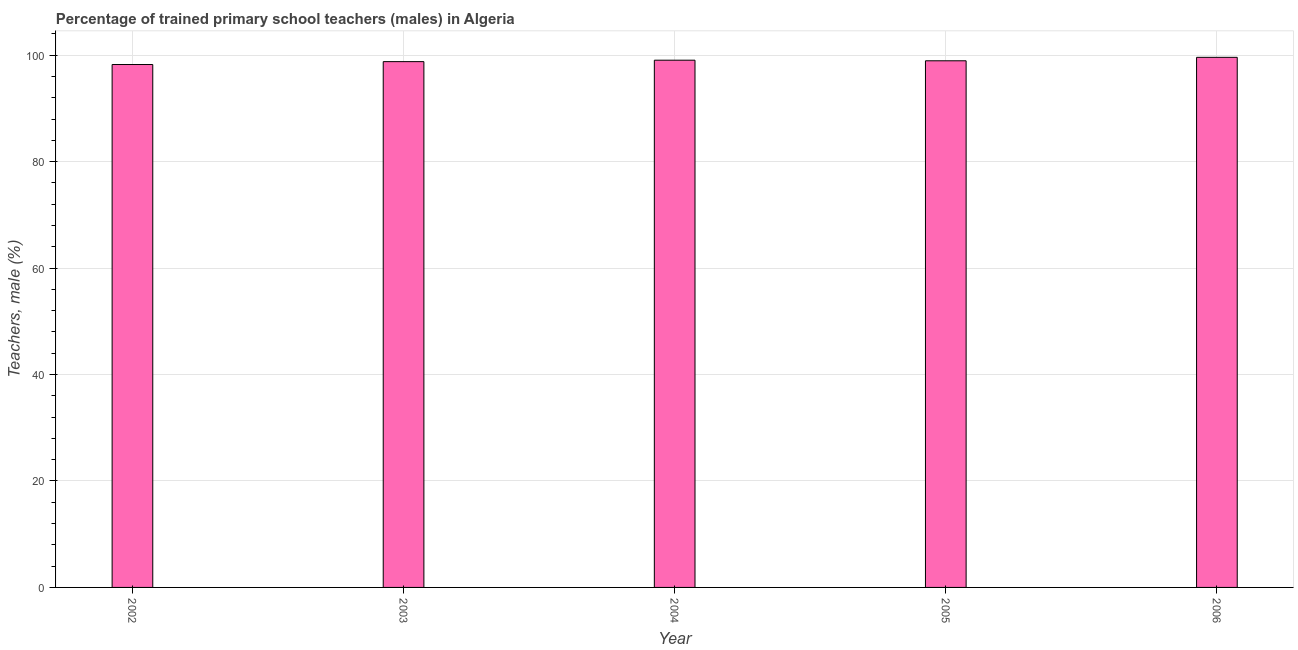Does the graph contain any zero values?
Provide a succinct answer. No. Does the graph contain grids?
Provide a short and direct response. Yes. What is the title of the graph?
Offer a very short reply. Percentage of trained primary school teachers (males) in Algeria. What is the label or title of the Y-axis?
Your response must be concise. Teachers, male (%). What is the percentage of trained male teachers in 2002?
Give a very brief answer. 98.25. Across all years, what is the maximum percentage of trained male teachers?
Your response must be concise. 99.6. Across all years, what is the minimum percentage of trained male teachers?
Offer a very short reply. 98.25. In which year was the percentage of trained male teachers minimum?
Provide a succinct answer. 2002. What is the sum of the percentage of trained male teachers?
Your answer should be very brief. 494.64. What is the difference between the percentage of trained male teachers in 2002 and 2005?
Give a very brief answer. -0.7. What is the average percentage of trained male teachers per year?
Your response must be concise. 98.93. What is the median percentage of trained male teachers?
Give a very brief answer. 98.95. Do a majority of the years between 2002 and 2003 (inclusive) have percentage of trained male teachers greater than 84 %?
Your answer should be very brief. Yes. What is the difference between the highest and the second highest percentage of trained male teachers?
Your answer should be compact. 0.54. What is the difference between the highest and the lowest percentage of trained male teachers?
Offer a very short reply. 1.35. In how many years, is the percentage of trained male teachers greater than the average percentage of trained male teachers taken over all years?
Your answer should be very brief. 3. How many bars are there?
Give a very brief answer. 5. Are all the bars in the graph horizontal?
Keep it short and to the point. No. What is the Teachers, male (%) in 2002?
Offer a terse response. 98.25. What is the Teachers, male (%) in 2003?
Provide a succinct answer. 98.79. What is the Teachers, male (%) in 2004?
Your answer should be compact. 99.06. What is the Teachers, male (%) of 2005?
Give a very brief answer. 98.95. What is the Teachers, male (%) in 2006?
Provide a succinct answer. 99.6. What is the difference between the Teachers, male (%) in 2002 and 2003?
Offer a very short reply. -0.54. What is the difference between the Teachers, male (%) in 2002 and 2004?
Your answer should be very brief. -0.81. What is the difference between the Teachers, male (%) in 2002 and 2005?
Your answer should be very brief. -0.7. What is the difference between the Teachers, male (%) in 2002 and 2006?
Give a very brief answer. -1.35. What is the difference between the Teachers, male (%) in 2003 and 2004?
Give a very brief answer. -0.27. What is the difference between the Teachers, male (%) in 2003 and 2005?
Offer a terse response. -0.16. What is the difference between the Teachers, male (%) in 2003 and 2006?
Your answer should be very brief. -0.81. What is the difference between the Teachers, male (%) in 2004 and 2005?
Keep it short and to the point. 0.11. What is the difference between the Teachers, male (%) in 2004 and 2006?
Your response must be concise. -0.54. What is the difference between the Teachers, male (%) in 2005 and 2006?
Keep it short and to the point. -0.65. What is the ratio of the Teachers, male (%) in 2003 to that in 2005?
Your answer should be very brief. 1. What is the ratio of the Teachers, male (%) in 2004 to that in 2005?
Provide a succinct answer. 1. What is the ratio of the Teachers, male (%) in 2004 to that in 2006?
Ensure brevity in your answer.  0.99. What is the ratio of the Teachers, male (%) in 2005 to that in 2006?
Ensure brevity in your answer.  0.99. 